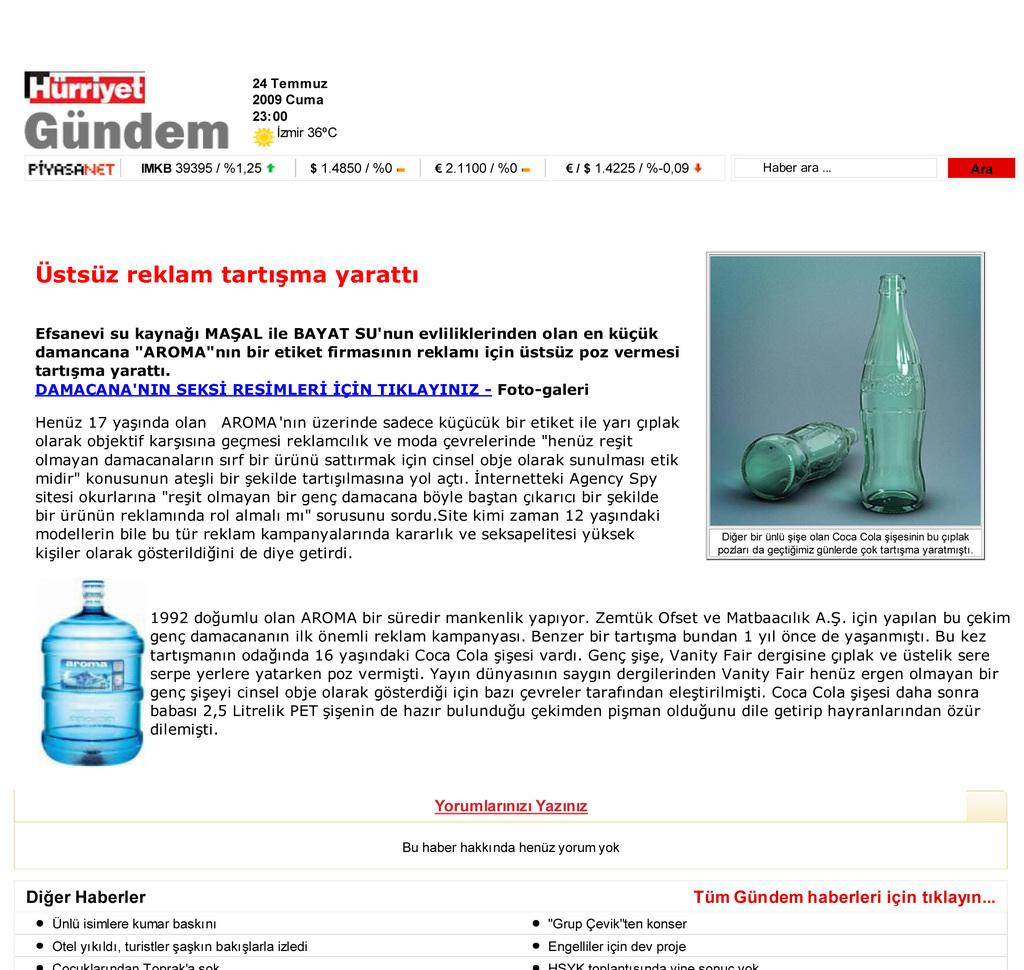Provide a one-sentence caption for the provided image. An advertisement has the word Hurriyet at the top of the page. 